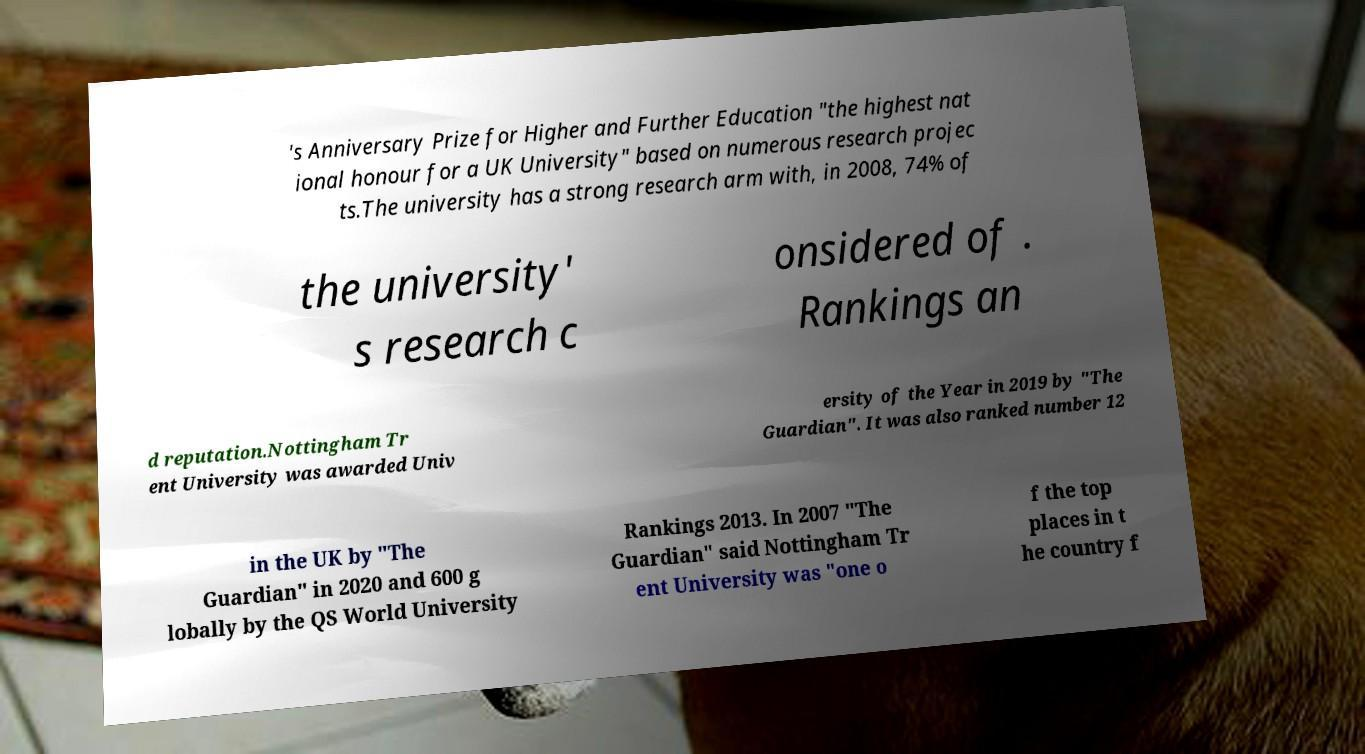There's text embedded in this image that I need extracted. Can you transcribe it verbatim? 's Anniversary Prize for Higher and Further Education "the highest nat ional honour for a UK University" based on numerous research projec ts.The university has a strong research arm with, in 2008, 74% of the university' s research c onsidered of . Rankings an d reputation.Nottingham Tr ent University was awarded Univ ersity of the Year in 2019 by "The Guardian". It was also ranked number 12 in the UK by "The Guardian" in 2020 and 600 g lobally by the QS World University Rankings 2013. In 2007 "The Guardian" said Nottingham Tr ent University was "one o f the top places in t he country f 